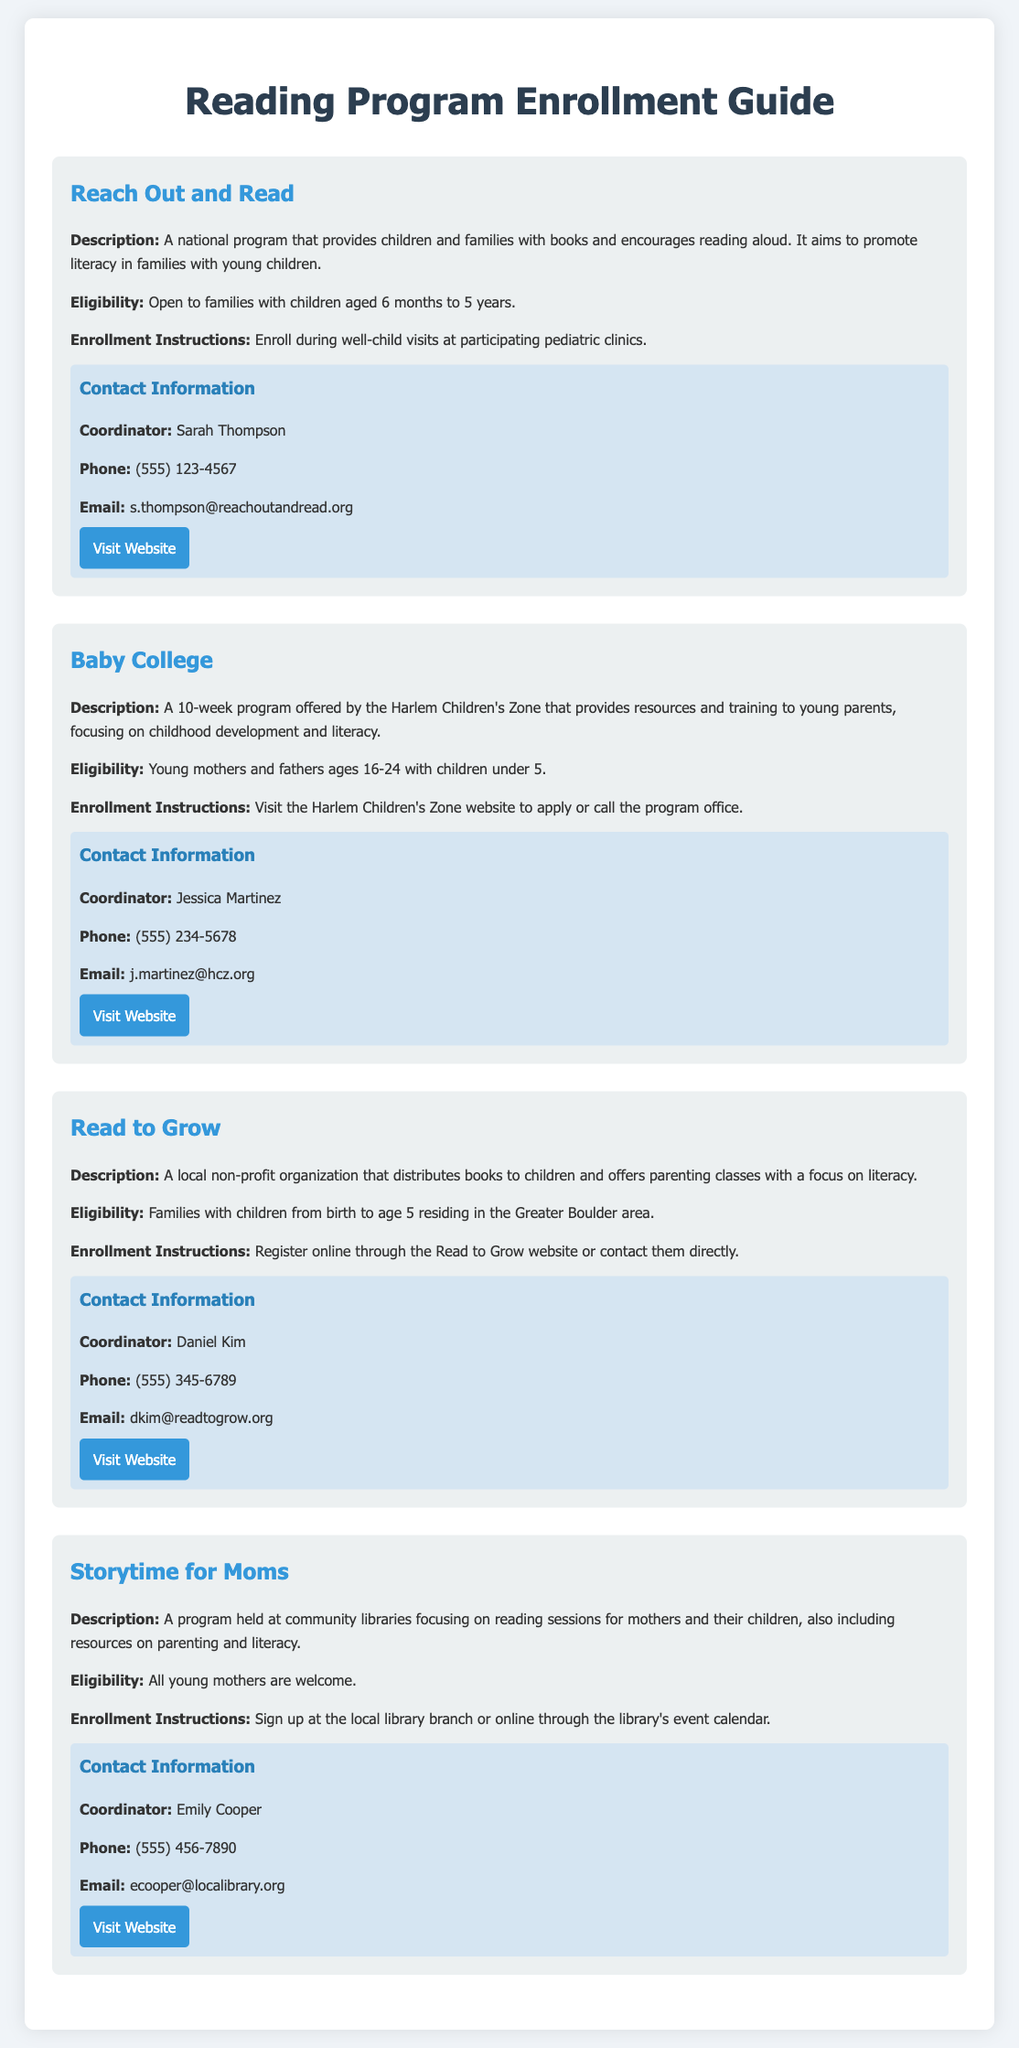What is the name of the first program listed? The first program mentioned in the document is titled "Reach Out and Read."
Answer: Reach Out and Read What is the age range for eligibility in the Baby College program? The eligibility for the Baby College program is specifically for young mothers and fathers ages 16-24.
Answer: 16-24 Who is the coordinator for the Read to Grow program? The coordinator for the Read to Grow program is Daniel Kim, as stated in the contact information section.
Answer: Daniel Kim How can one enroll in the Storytime for Moms program? Enrollment in the Storytime for Moms program can be done at the local library branch or online.
Answer: Local library branch or online What is a common focus of all the programs listed? All the programs emphasize promoting literacy among children and families.
Answer: Promoting literacy What is the phone number for the coordinator of the Reach Out and Read program? The phone number for the Reach Out and Read program coordinator, Sarah Thompson, is listed in the document.
Answer: (555) 123-4567 Which program requires enrollment during well-child visits? The enrollment for the Reach Out and Read program takes place during well-child visits at pediatric clinics.
Answer: Reach Out and Read How long is the Baby College program? The Baby College program is described as a 10-week program.
Answer: 10 weeks Which program is open to all young mothers? The Storytime for Moms program is explicitly stated as being open to all young mothers.
Answer: Storytime for Moms 